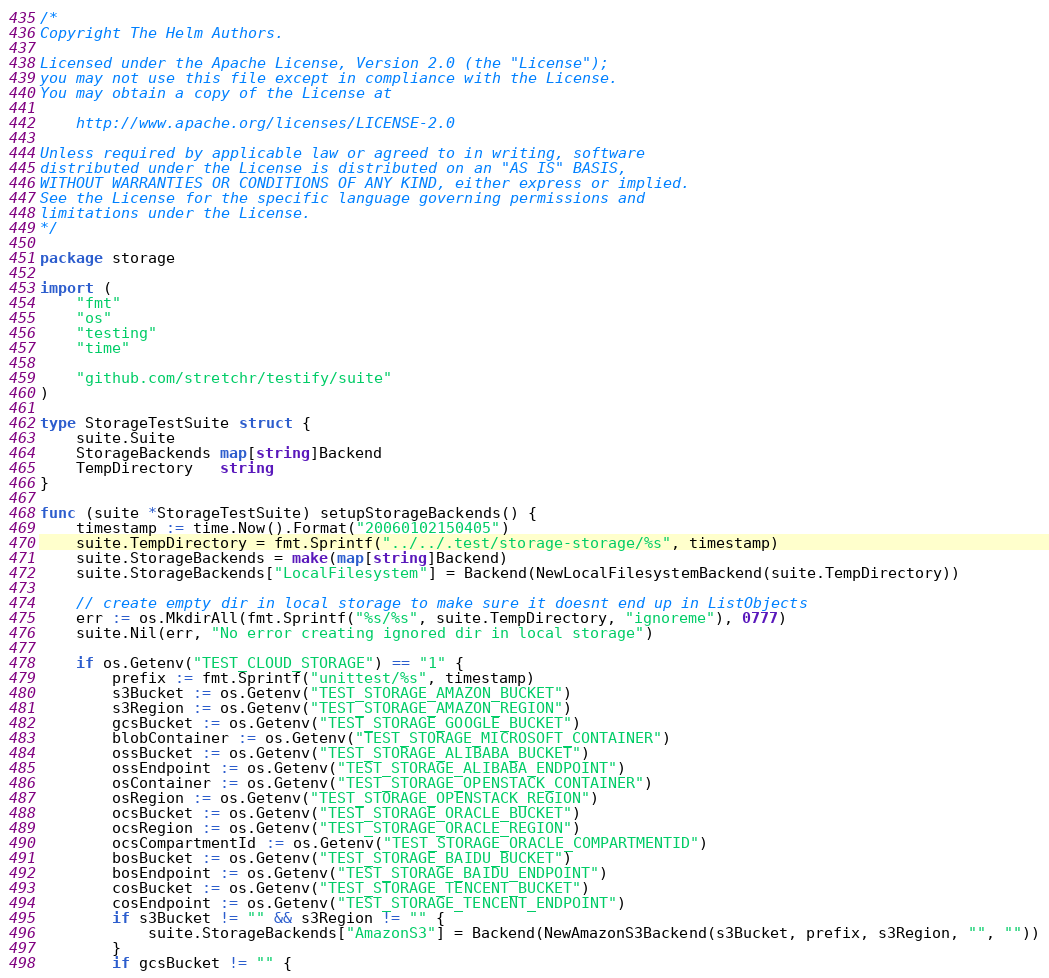Convert code to text. <code><loc_0><loc_0><loc_500><loc_500><_Go_>/*
Copyright The Helm Authors.

Licensed under the Apache License, Version 2.0 (the "License");
you may not use this file except in compliance with the License.
You may obtain a copy of the License at

    http://www.apache.org/licenses/LICENSE-2.0

Unless required by applicable law or agreed to in writing, software
distributed under the License is distributed on an "AS IS" BASIS,
WITHOUT WARRANTIES OR CONDITIONS OF ANY KIND, either express or implied.
See the License for the specific language governing permissions and
limitations under the License.
*/

package storage

import (
	"fmt"
	"os"
	"testing"
	"time"

	"github.com/stretchr/testify/suite"
)

type StorageTestSuite struct {
	suite.Suite
	StorageBackends map[string]Backend
	TempDirectory   string
}

func (suite *StorageTestSuite) setupStorageBackends() {
	timestamp := time.Now().Format("20060102150405")
	suite.TempDirectory = fmt.Sprintf("../../.test/storage-storage/%s", timestamp)
	suite.StorageBackends = make(map[string]Backend)
	suite.StorageBackends["LocalFilesystem"] = Backend(NewLocalFilesystemBackend(suite.TempDirectory))

	// create empty dir in local storage to make sure it doesnt end up in ListObjects
	err := os.MkdirAll(fmt.Sprintf("%s/%s", suite.TempDirectory, "ignoreme"), 0777)
	suite.Nil(err, "No error creating ignored dir in local storage")

	if os.Getenv("TEST_CLOUD_STORAGE") == "1" {
		prefix := fmt.Sprintf("unittest/%s", timestamp)
		s3Bucket := os.Getenv("TEST_STORAGE_AMAZON_BUCKET")
		s3Region := os.Getenv("TEST_STORAGE_AMAZON_REGION")
		gcsBucket := os.Getenv("TEST_STORAGE_GOOGLE_BUCKET")
		blobContainer := os.Getenv("TEST_STORAGE_MICROSOFT_CONTAINER")
		ossBucket := os.Getenv("TEST_STORAGE_ALIBABA_BUCKET")
		ossEndpoint := os.Getenv("TEST_STORAGE_ALIBABA_ENDPOINT")
		osContainer := os.Getenv("TEST_STORAGE_OPENSTACK_CONTAINER")
		osRegion := os.Getenv("TEST_STORAGE_OPENSTACK_REGION")
		ocsBucket := os.Getenv("TEST_STORAGE_ORACLE_BUCKET")
		ocsRegion := os.Getenv("TEST_STORAGE_ORACLE_REGION")
		ocsCompartmentId := os.Getenv("TEST_STORAGE_ORACLE_COMPARTMENTID")
		bosBucket := os.Getenv("TEST_STORAGE_BAIDU_BUCKET")
		bosEndpoint := os.Getenv("TEST_STORAGE_BAIDU_ENDPOINT")
		cosBucket := os.Getenv("TEST_STORAGE_TENCENT_BUCKET")
		cosEndpoint := os.Getenv("TEST_STORAGE_TENCENT_ENDPOINT")
		if s3Bucket != "" && s3Region != "" {
			suite.StorageBackends["AmazonS3"] = Backend(NewAmazonS3Backend(s3Bucket, prefix, s3Region, "", ""))
		}
		if gcsBucket != "" {</code> 